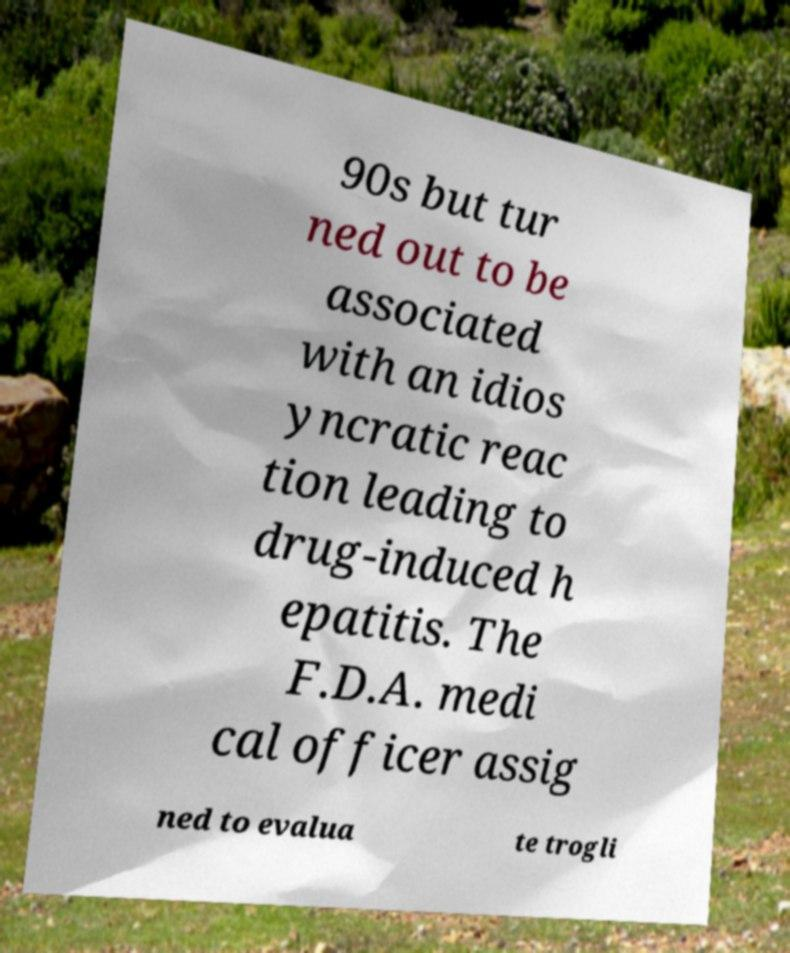For documentation purposes, I need the text within this image transcribed. Could you provide that? 90s but tur ned out to be associated with an idios yncratic reac tion leading to drug-induced h epatitis. The F.D.A. medi cal officer assig ned to evalua te trogli 